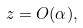Convert formula to latex. <formula><loc_0><loc_0><loc_500><loc_500>z = O ( \alpha ) ,</formula> 